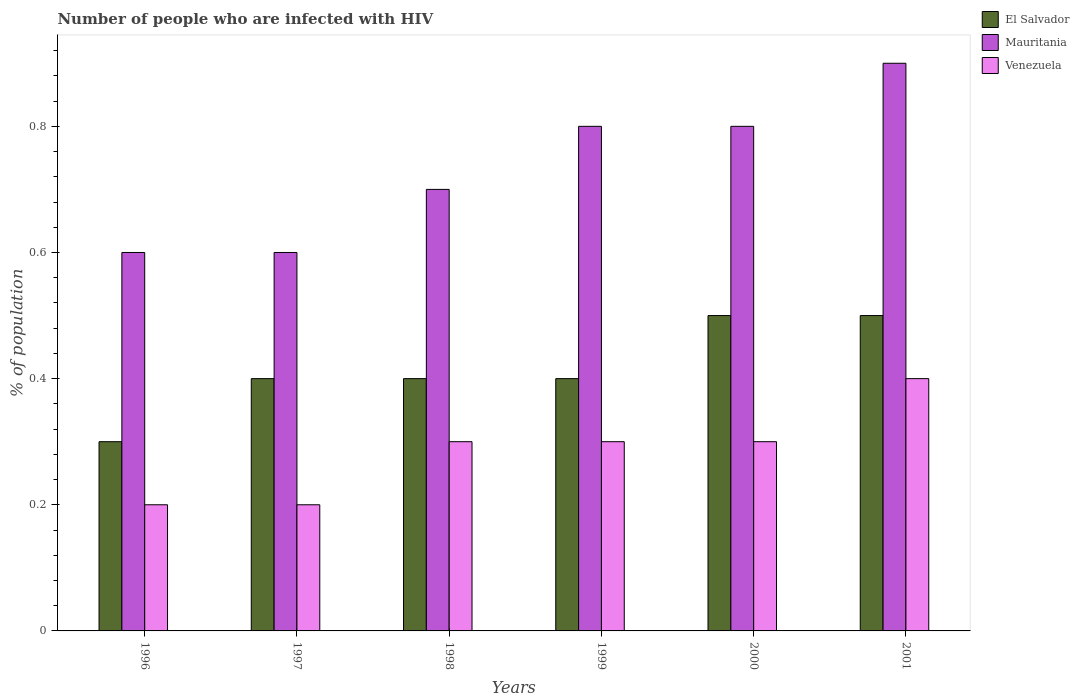How many different coloured bars are there?
Provide a succinct answer. 3. How many groups of bars are there?
Make the answer very short. 6. Are the number of bars per tick equal to the number of legend labels?
Ensure brevity in your answer.  Yes. Are the number of bars on each tick of the X-axis equal?
Offer a very short reply. Yes. How many bars are there on the 6th tick from the right?
Give a very brief answer. 3. In how many cases, is the number of bars for a given year not equal to the number of legend labels?
Ensure brevity in your answer.  0. Across all years, what is the minimum percentage of HIV infected population in in Venezuela?
Offer a very short reply. 0.2. In which year was the percentage of HIV infected population in in El Salvador minimum?
Ensure brevity in your answer.  1996. What is the total percentage of HIV infected population in in El Salvador in the graph?
Your response must be concise. 2.5. What is the difference between the percentage of HIV infected population in in Mauritania in 1996 and that in 1999?
Provide a short and direct response. -0.2. What is the average percentage of HIV infected population in in El Salvador per year?
Offer a very short reply. 0.42. In the year 1997, what is the difference between the percentage of HIV infected population in in Mauritania and percentage of HIV infected population in in Venezuela?
Your answer should be very brief. 0.4. In how many years, is the percentage of HIV infected population in in Mauritania greater than 0.56 %?
Your answer should be very brief. 6. What is the ratio of the percentage of HIV infected population in in Venezuela in 1999 to that in 2001?
Make the answer very short. 0.75. What is the difference between the highest and the second highest percentage of HIV infected population in in Mauritania?
Offer a terse response. 0.1. In how many years, is the percentage of HIV infected population in in Venezuela greater than the average percentage of HIV infected population in in Venezuela taken over all years?
Your response must be concise. 4. Is the sum of the percentage of HIV infected population in in Mauritania in 1998 and 1999 greater than the maximum percentage of HIV infected population in in Venezuela across all years?
Your answer should be very brief. Yes. What does the 2nd bar from the left in 1997 represents?
Offer a terse response. Mauritania. What does the 2nd bar from the right in 2001 represents?
Provide a short and direct response. Mauritania. Is it the case that in every year, the sum of the percentage of HIV infected population in in El Salvador and percentage of HIV infected population in in Venezuela is greater than the percentage of HIV infected population in in Mauritania?
Your response must be concise. No. How many years are there in the graph?
Make the answer very short. 6. Does the graph contain grids?
Provide a succinct answer. No. What is the title of the graph?
Offer a very short reply. Number of people who are infected with HIV. Does "Guatemala" appear as one of the legend labels in the graph?
Keep it short and to the point. No. What is the label or title of the X-axis?
Make the answer very short. Years. What is the label or title of the Y-axis?
Provide a succinct answer. % of population. What is the % of population of Mauritania in 1996?
Ensure brevity in your answer.  0.6. What is the % of population in El Salvador in 1998?
Keep it short and to the point. 0.4. What is the % of population in Mauritania in 1999?
Your response must be concise. 0.8. What is the % of population in Venezuela in 1999?
Your answer should be very brief. 0.3. What is the % of population of El Salvador in 2000?
Provide a short and direct response. 0.5. What is the % of population of Mauritania in 2000?
Your response must be concise. 0.8. Across all years, what is the minimum % of population in El Salvador?
Provide a short and direct response. 0.3. Across all years, what is the minimum % of population in Mauritania?
Offer a terse response. 0.6. What is the total % of population of Venezuela in the graph?
Your answer should be very brief. 1.7. What is the difference between the % of population in El Salvador in 1996 and that in 1997?
Offer a terse response. -0.1. What is the difference between the % of population in El Salvador in 1996 and that in 1998?
Your answer should be compact. -0.1. What is the difference between the % of population of Venezuela in 1996 and that in 1998?
Provide a short and direct response. -0.1. What is the difference between the % of population in Mauritania in 1996 and that in 1999?
Provide a succinct answer. -0.2. What is the difference between the % of population in Venezuela in 1996 and that in 2000?
Offer a terse response. -0.1. What is the difference between the % of population in El Salvador in 1996 and that in 2001?
Ensure brevity in your answer.  -0.2. What is the difference between the % of population in Venezuela in 1996 and that in 2001?
Offer a very short reply. -0.2. What is the difference between the % of population of El Salvador in 1997 and that in 1998?
Give a very brief answer. 0. What is the difference between the % of population of El Salvador in 1997 and that in 1999?
Your answer should be very brief. 0. What is the difference between the % of population of Mauritania in 1997 and that in 1999?
Provide a succinct answer. -0.2. What is the difference between the % of population in Mauritania in 1997 and that in 2000?
Ensure brevity in your answer.  -0.2. What is the difference between the % of population in Mauritania in 1997 and that in 2001?
Make the answer very short. -0.3. What is the difference between the % of population in Venezuela in 1997 and that in 2001?
Keep it short and to the point. -0.2. What is the difference between the % of population in El Salvador in 1998 and that in 1999?
Provide a succinct answer. 0. What is the difference between the % of population of Mauritania in 1998 and that in 1999?
Make the answer very short. -0.1. What is the difference between the % of population of Venezuela in 1998 and that in 1999?
Provide a short and direct response. 0. What is the difference between the % of population of El Salvador in 1998 and that in 2000?
Your response must be concise. -0.1. What is the difference between the % of population in Mauritania in 1998 and that in 2000?
Your answer should be compact. -0.1. What is the difference between the % of population of Venezuela in 1998 and that in 2000?
Keep it short and to the point. 0. What is the difference between the % of population of Mauritania in 1998 and that in 2001?
Keep it short and to the point. -0.2. What is the difference between the % of population in Venezuela in 1998 and that in 2001?
Offer a terse response. -0.1. What is the difference between the % of population in El Salvador in 1999 and that in 2000?
Provide a short and direct response. -0.1. What is the difference between the % of population in Venezuela in 1999 and that in 2000?
Ensure brevity in your answer.  0. What is the difference between the % of population of El Salvador in 2000 and that in 2001?
Your response must be concise. 0. What is the difference between the % of population in El Salvador in 1996 and the % of population in Venezuela in 1997?
Ensure brevity in your answer.  0.1. What is the difference between the % of population in Mauritania in 1996 and the % of population in Venezuela in 1997?
Your response must be concise. 0.4. What is the difference between the % of population of El Salvador in 1996 and the % of population of Venezuela in 1998?
Keep it short and to the point. 0. What is the difference between the % of population in El Salvador in 1996 and the % of population in Venezuela in 2000?
Provide a succinct answer. 0. What is the difference between the % of population of Mauritania in 1996 and the % of population of Venezuela in 2000?
Keep it short and to the point. 0.3. What is the difference between the % of population of El Salvador in 1996 and the % of population of Mauritania in 2001?
Offer a very short reply. -0.6. What is the difference between the % of population in El Salvador in 1996 and the % of population in Venezuela in 2001?
Your answer should be compact. -0.1. What is the difference between the % of population in Mauritania in 1996 and the % of population in Venezuela in 2001?
Make the answer very short. 0.2. What is the difference between the % of population of El Salvador in 1997 and the % of population of Mauritania in 1998?
Keep it short and to the point. -0.3. What is the difference between the % of population in Mauritania in 1997 and the % of population in Venezuela in 1998?
Offer a very short reply. 0.3. What is the difference between the % of population in Mauritania in 1997 and the % of population in Venezuela in 1999?
Give a very brief answer. 0.3. What is the difference between the % of population in El Salvador in 1997 and the % of population in Venezuela in 2001?
Your answer should be compact. 0. What is the difference between the % of population in Mauritania in 1998 and the % of population in Venezuela in 1999?
Ensure brevity in your answer.  0.4. What is the difference between the % of population in El Salvador in 1998 and the % of population in Mauritania in 2000?
Give a very brief answer. -0.4. What is the difference between the % of population in Mauritania in 1998 and the % of population in Venezuela in 2000?
Your answer should be compact. 0.4. What is the difference between the % of population in El Salvador in 1998 and the % of population in Mauritania in 2001?
Your response must be concise. -0.5. What is the difference between the % of population of El Salvador in 1998 and the % of population of Venezuela in 2001?
Provide a succinct answer. 0. What is the difference between the % of population in El Salvador in 1999 and the % of population in Mauritania in 2001?
Your response must be concise. -0.5. What is the difference between the % of population of El Salvador in 1999 and the % of population of Venezuela in 2001?
Ensure brevity in your answer.  0. What is the difference between the % of population of Mauritania in 1999 and the % of population of Venezuela in 2001?
Offer a terse response. 0.4. What is the difference between the % of population of El Salvador in 2000 and the % of population of Venezuela in 2001?
Your answer should be very brief. 0.1. What is the average % of population of El Salvador per year?
Give a very brief answer. 0.42. What is the average % of population in Mauritania per year?
Provide a succinct answer. 0.73. What is the average % of population of Venezuela per year?
Your answer should be very brief. 0.28. In the year 1996, what is the difference between the % of population of El Salvador and % of population of Mauritania?
Offer a terse response. -0.3. In the year 1996, what is the difference between the % of population of Mauritania and % of population of Venezuela?
Give a very brief answer. 0.4. In the year 1997, what is the difference between the % of population in El Salvador and % of population in Mauritania?
Give a very brief answer. -0.2. In the year 1997, what is the difference between the % of population in El Salvador and % of population in Venezuela?
Provide a short and direct response. 0.2. In the year 1998, what is the difference between the % of population of Mauritania and % of population of Venezuela?
Your answer should be very brief. 0.4. In the year 1999, what is the difference between the % of population in El Salvador and % of population in Mauritania?
Your answer should be very brief. -0.4. In the year 1999, what is the difference between the % of population of El Salvador and % of population of Venezuela?
Offer a very short reply. 0.1. In the year 1999, what is the difference between the % of population in Mauritania and % of population in Venezuela?
Give a very brief answer. 0.5. In the year 2000, what is the difference between the % of population of El Salvador and % of population of Venezuela?
Provide a succinct answer. 0.2. In the year 2000, what is the difference between the % of population of Mauritania and % of population of Venezuela?
Offer a terse response. 0.5. In the year 2001, what is the difference between the % of population in El Salvador and % of population in Venezuela?
Offer a terse response. 0.1. In the year 2001, what is the difference between the % of population of Mauritania and % of population of Venezuela?
Your answer should be very brief. 0.5. What is the ratio of the % of population of Mauritania in 1996 to that in 1997?
Provide a short and direct response. 1. What is the ratio of the % of population in El Salvador in 1996 to that in 1999?
Offer a very short reply. 0.75. What is the ratio of the % of population in Venezuela in 1996 to that in 1999?
Offer a terse response. 0.67. What is the ratio of the % of population of El Salvador in 1996 to that in 2000?
Offer a very short reply. 0.6. What is the ratio of the % of population in Mauritania in 1996 to that in 2001?
Keep it short and to the point. 0.67. What is the ratio of the % of population in Venezuela in 1996 to that in 2001?
Keep it short and to the point. 0.5. What is the ratio of the % of population in El Salvador in 1997 to that in 1998?
Your response must be concise. 1. What is the ratio of the % of population in El Salvador in 1997 to that in 1999?
Your answer should be very brief. 1. What is the ratio of the % of population of Mauritania in 1997 to that in 1999?
Your response must be concise. 0.75. What is the ratio of the % of population of Venezuela in 1997 to that in 1999?
Your answer should be very brief. 0.67. What is the ratio of the % of population of El Salvador in 1997 to that in 2000?
Provide a short and direct response. 0.8. What is the ratio of the % of population of Venezuela in 1997 to that in 2000?
Your response must be concise. 0.67. What is the ratio of the % of population of El Salvador in 1997 to that in 2001?
Your answer should be compact. 0.8. What is the ratio of the % of population of Mauritania in 1997 to that in 2001?
Make the answer very short. 0.67. What is the ratio of the % of population in Venezuela in 1997 to that in 2001?
Give a very brief answer. 0.5. What is the ratio of the % of population of Mauritania in 1998 to that in 1999?
Offer a terse response. 0.88. What is the ratio of the % of population in Venezuela in 1998 to that in 1999?
Give a very brief answer. 1. What is the ratio of the % of population in El Salvador in 1998 to that in 2000?
Your answer should be compact. 0.8. What is the ratio of the % of population in Mauritania in 1998 to that in 2000?
Provide a short and direct response. 0.88. What is the ratio of the % of population of El Salvador in 1998 to that in 2001?
Your answer should be very brief. 0.8. What is the ratio of the % of population of Venezuela in 1998 to that in 2001?
Offer a very short reply. 0.75. What is the ratio of the % of population of El Salvador in 1999 to that in 2000?
Provide a short and direct response. 0.8. What is the ratio of the % of population in Mauritania in 1999 to that in 2000?
Provide a short and direct response. 1. What is the ratio of the % of population of El Salvador in 1999 to that in 2001?
Your answer should be compact. 0.8. What is the ratio of the % of population of Mauritania in 1999 to that in 2001?
Your answer should be very brief. 0.89. What is the ratio of the % of population of Venezuela in 1999 to that in 2001?
Offer a very short reply. 0.75. What is the difference between the highest and the second highest % of population of El Salvador?
Provide a succinct answer. 0. What is the difference between the highest and the lowest % of population of Mauritania?
Your answer should be very brief. 0.3. What is the difference between the highest and the lowest % of population of Venezuela?
Your answer should be compact. 0.2. 